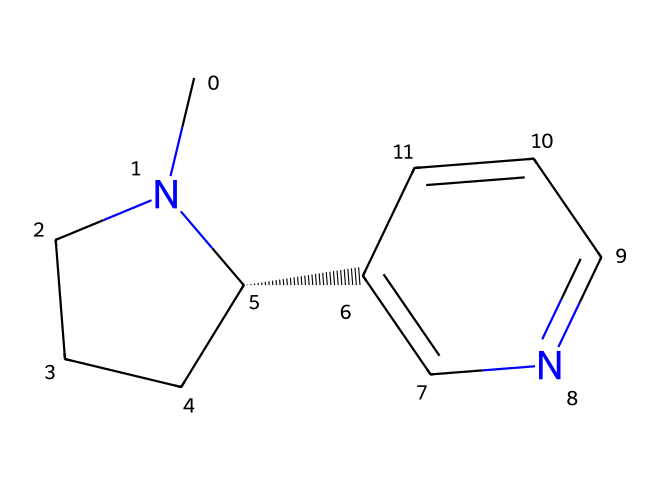What is the molecular formula of nicotine? The provided SMILES can be deciphered to determine the number of each type of atom present. By analyzing the structure, nicotine has 10 carbons, 14 hydrogens, and 2 nitrogens. Thus, the molecular formula can be written as C10H14N2.
Answer: C10H14N2 How many rings are present in the structure of nicotine? Looking at the visual representation derived from the SMILES, nicotine contains two ring systems - one piperidine ring and one pyridine ring.
Answer: 2 What type of chemical is nicotine classified as? The structure, characterized by a nitrogen-containing ring and an alkaloid structure, classifies nicotine as a type of alkaloid; mainly due to the presence of nitrogen.
Answer: alkaloid What property does the nitrogen atom confer to nicotine? The nitrogen atom in nicotine contributes to its behavior as a basic compound, impacting its interaction with biological systems, especially in terms of neurotransmitter activity.
Answer: basicity Which elements predominantly compose nicotine? The analysis of the molecular structure indicates that nicotine predominantly consists of carbon, hydrogen, and nitrogen which are the primary elements that form this compound.
Answer: carbon, hydrogen, nitrogen What effect does the presence of the pyridine ring have on nicotine's behavior? The pyridine ring contributes to the properties of nicotine by influencing its aromaticity and polar characteristics, thus affecting its solubility and interaction with receptors.
Answer: affects solubility, interacts with receptors What kind of hybridization is present in the carbon atoms of nicotine? The majority of carbon atoms in nicotine exhibit sp3 hybridization (in the saturated piperidine part) and sp2 hybridization (in the aromatic pyridine part), revealing its structural complexity.
Answer: sp3, sp2 